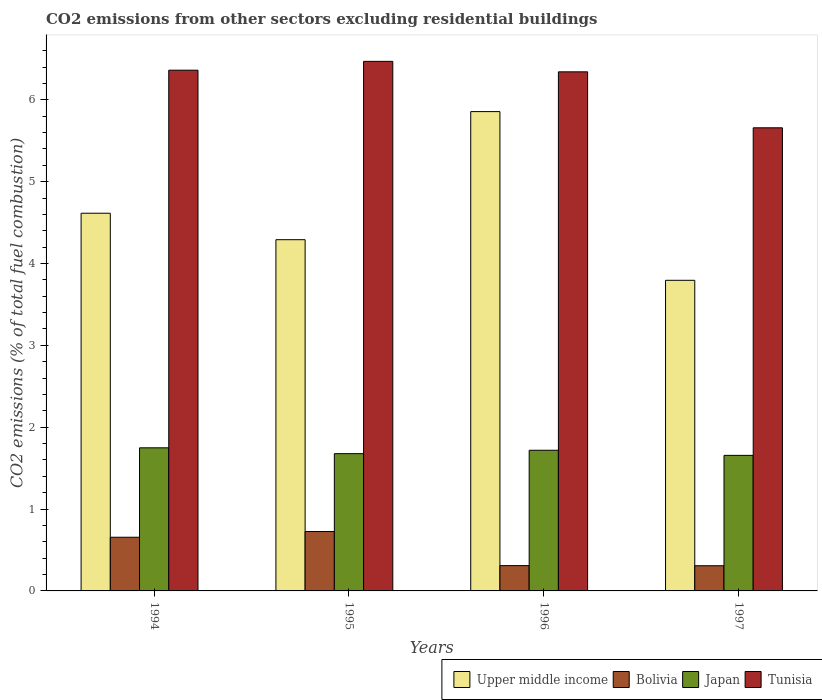How many different coloured bars are there?
Give a very brief answer. 4. How many groups of bars are there?
Offer a terse response. 4. Are the number of bars per tick equal to the number of legend labels?
Your answer should be very brief. Yes. How many bars are there on the 4th tick from the left?
Your answer should be very brief. 4. What is the label of the 1st group of bars from the left?
Keep it short and to the point. 1994. In how many cases, is the number of bars for a given year not equal to the number of legend labels?
Offer a very short reply. 0. What is the total CO2 emitted in Bolivia in 1997?
Provide a short and direct response. 0.31. Across all years, what is the maximum total CO2 emitted in Bolivia?
Offer a very short reply. 0.73. Across all years, what is the minimum total CO2 emitted in Japan?
Your response must be concise. 1.66. In which year was the total CO2 emitted in Bolivia minimum?
Offer a very short reply. 1997. What is the total total CO2 emitted in Japan in the graph?
Provide a short and direct response. 6.8. What is the difference between the total CO2 emitted in Bolivia in 1996 and that in 1997?
Give a very brief answer. 0. What is the difference between the total CO2 emitted in Tunisia in 1997 and the total CO2 emitted in Upper middle income in 1995?
Keep it short and to the point. 1.37. What is the average total CO2 emitted in Bolivia per year?
Your answer should be compact. 0.5. In the year 1995, what is the difference between the total CO2 emitted in Upper middle income and total CO2 emitted in Bolivia?
Provide a short and direct response. 3.57. What is the ratio of the total CO2 emitted in Bolivia in 1995 to that in 1997?
Provide a short and direct response. 2.36. What is the difference between the highest and the second highest total CO2 emitted in Tunisia?
Provide a short and direct response. 0.11. What is the difference between the highest and the lowest total CO2 emitted in Japan?
Offer a terse response. 0.09. Is the sum of the total CO2 emitted in Bolivia in 1994 and 1995 greater than the maximum total CO2 emitted in Japan across all years?
Your response must be concise. No. What does the 4th bar from the left in 1996 represents?
Offer a terse response. Tunisia. What does the 4th bar from the right in 1994 represents?
Give a very brief answer. Upper middle income. Is it the case that in every year, the sum of the total CO2 emitted in Japan and total CO2 emitted in Bolivia is greater than the total CO2 emitted in Upper middle income?
Give a very brief answer. No. Are all the bars in the graph horizontal?
Ensure brevity in your answer.  No. How many years are there in the graph?
Give a very brief answer. 4. Does the graph contain any zero values?
Make the answer very short. No. What is the title of the graph?
Ensure brevity in your answer.  CO2 emissions from other sectors excluding residential buildings. Does "Israel" appear as one of the legend labels in the graph?
Make the answer very short. No. What is the label or title of the Y-axis?
Provide a succinct answer. CO2 emissions (% of total fuel combustion). What is the CO2 emissions (% of total fuel combustion) of Upper middle income in 1994?
Make the answer very short. 4.61. What is the CO2 emissions (% of total fuel combustion) in Bolivia in 1994?
Offer a terse response. 0.66. What is the CO2 emissions (% of total fuel combustion) of Japan in 1994?
Keep it short and to the point. 1.75. What is the CO2 emissions (% of total fuel combustion) in Tunisia in 1994?
Make the answer very short. 6.36. What is the CO2 emissions (% of total fuel combustion) in Upper middle income in 1995?
Offer a very short reply. 4.29. What is the CO2 emissions (% of total fuel combustion) of Bolivia in 1995?
Ensure brevity in your answer.  0.73. What is the CO2 emissions (% of total fuel combustion) in Japan in 1995?
Your response must be concise. 1.68. What is the CO2 emissions (% of total fuel combustion) in Tunisia in 1995?
Provide a short and direct response. 6.47. What is the CO2 emissions (% of total fuel combustion) in Upper middle income in 1996?
Your answer should be compact. 5.86. What is the CO2 emissions (% of total fuel combustion) of Bolivia in 1996?
Offer a terse response. 0.31. What is the CO2 emissions (% of total fuel combustion) in Japan in 1996?
Your answer should be compact. 1.72. What is the CO2 emissions (% of total fuel combustion) of Tunisia in 1996?
Ensure brevity in your answer.  6.34. What is the CO2 emissions (% of total fuel combustion) of Upper middle income in 1997?
Offer a terse response. 3.79. What is the CO2 emissions (% of total fuel combustion) of Bolivia in 1997?
Ensure brevity in your answer.  0.31. What is the CO2 emissions (% of total fuel combustion) in Japan in 1997?
Offer a very short reply. 1.66. What is the CO2 emissions (% of total fuel combustion) of Tunisia in 1997?
Offer a very short reply. 5.66. Across all years, what is the maximum CO2 emissions (% of total fuel combustion) in Upper middle income?
Provide a succinct answer. 5.86. Across all years, what is the maximum CO2 emissions (% of total fuel combustion) in Bolivia?
Ensure brevity in your answer.  0.73. Across all years, what is the maximum CO2 emissions (% of total fuel combustion) in Japan?
Give a very brief answer. 1.75. Across all years, what is the maximum CO2 emissions (% of total fuel combustion) in Tunisia?
Keep it short and to the point. 6.47. Across all years, what is the minimum CO2 emissions (% of total fuel combustion) in Upper middle income?
Provide a short and direct response. 3.79. Across all years, what is the minimum CO2 emissions (% of total fuel combustion) in Bolivia?
Provide a succinct answer. 0.31. Across all years, what is the minimum CO2 emissions (% of total fuel combustion) in Japan?
Keep it short and to the point. 1.66. Across all years, what is the minimum CO2 emissions (% of total fuel combustion) of Tunisia?
Ensure brevity in your answer.  5.66. What is the total CO2 emissions (% of total fuel combustion) in Upper middle income in the graph?
Keep it short and to the point. 18.56. What is the total CO2 emissions (% of total fuel combustion) of Bolivia in the graph?
Ensure brevity in your answer.  2. What is the total CO2 emissions (% of total fuel combustion) of Japan in the graph?
Your answer should be compact. 6.8. What is the total CO2 emissions (% of total fuel combustion) of Tunisia in the graph?
Provide a succinct answer. 24.83. What is the difference between the CO2 emissions (% of total fuel combustion) of Upper middle income in 1994 and that in 1995?
Keep it short and to the point. 0.32. What is the difference between the CO2 emissions (% of total fuel combustion) in Bolivia in 1994 and that in 1995?
Offer a very short reply. -0.07. What is the difference between the CO2 emissions (% of total fuel combustion) of Japan in 1994 and that in 1995?
Offer a very short reply. 0.07. What is the difference between the CO2 emissions (% of total fuel combustion) in Tunisia in 1994 and that in 1995?
Your response must be concise. -0.11. What is the difference between the CO2 emissions (% of total fuel combustion) of Upper middle income in 1994 and that in 1996?
Offer a terse response. -1.24. What is the difference between the CO2 emissions (% of total fuel combustion) of Bolivia in 1994 and that in 1996?
Give a very brief answer. 0.35. What is the difference between the CO2 emissions (% of total fuel combustion) of Japan in 1994 and that in 1996?
Your response must be concise. 0.03. What is the difference between the CO2 emissions (% of total fuel combustion) of Tunisia in 1994 and that in 1996?
Give a very brief answer. 0.02. What is the difference between the CO2 emissions (% of total fuel combustion) in Upper middle income in 1994 and that in 1997?
Provide a succinct answer. 0.82. What is the difference between the CO2 emissions (% of total fuel combustion) in Bolivia in 1994 and that in 1997?
Offer a terse response. 0.35. What is the difference between the CO2 emissions (% of total fuel combustion) in Japan in 1994 and that in 1997?
Your response must be concise. 0.09. What is the difference between the CO2 emissions (% of total fuel combustion) in Tunisia in 1994 and that in 1997?
Your answer should be compact. 0.7. What is the difference between the CO2 emissions (% of total fuel combustion) of Upper middle income in 1995 and that in 1996?
Provide a short and direct response. -1.56. What is the difference between the CO2 emissions (% of total fuel combustion) of Bolivia in 1995 and that in 1996?
Offer a very short reply. 0.42. What is the difference between the CO2 emissions (% of total fuel combustion) in Japan in 1995 and that in 1996?
Make the answer very short. -0.04. What is the difference between the CO2 emissions (% of total fuel combustion) of Tunisia in 1995 and that in 1996?
Offer a terse response. 0.13. What is the difference between the CO2 emissions (% of total fuel combustion) in Upper middle income in 1995 and that in 1997?
Your response must be concise. 0.5. What is the difference between the CO2 emissions (% of total fuel combustion) of Bolivia in 1995 and that in 1997?
Ensure brevity in your answer.  0.42. What is the difference between the CO2 emissions (% of total fuel combustion) in Japan in 1995 and that in 1997?
Make the answer very short. 0.02. What is the difference between the CO2 emissions (% of total fuel combustion) in Tunisia in 1995 and that in 1997?
Your answer should be compact. 0.81. What is the difference between the CO2 emissions (% of total fuel combustion) of Upper middle income in 1996 and that in 1997?
Give a very brief answer. 2.06. What is the difference between the CO2 emissions (% of total fuel combustion) in Bolivia in 1996 and that in 1997?
Make the answer very short. 0. What is the difference between the CO2 emissions (% of total fuel combustion) of Japan in 1996 and that in 1997?
Ensure brevity in your answer.  0.06. What is the difference between the CO2 emissions (% of total fuel combustion) of Tunisia in 1996 and that in 1997?
Keep it short and to the point. 0.68. What is the difference between the CO2 emissions (% of total fuel combustion) in Upper middle income in 1994 and the CO2 emissions (% of total fuel combustion) in Bolivia in 1995?
Ensure brevity in your answer.  3.89. What is the difference between the CO2 emissions (% of total fuel combustion) in Upper middle income in 1994 and the CO2 emissions (% of total fuel combustion) in Japan in 1995?
Make the answer very short. 2.94. What is the difference between the CO2 emissions (% of total fuel combustion) in Upper middle income in 1994 and the CO2 emissions (% of total fuel combustion) in Tunisia in 1995?
Provide a short and direct response. -1.86. What is the difference between the CO2 emissions (% of total fuel combustion) in Bolivia in 1994 and the CO2 emissions (% of total fuel combustion) in Japan in 1995?
Offer a very short reply. -1.02. What is the difference between the CO2 emissions (% of total fuel combustion) of Bolivia in 1994 and the CO2 emissions (% of total fuel combustion) of Tunisia in 1995?
Your answer should be very brief. -5.81. What is the difference between the CO2 emissions (% of total fuel combustion) of Japan in 1994 and the CO2 emissions (% of total fuel combustion) of Tunisia in 1995?
Provide a short and direct response. -4.72. What is the difference between the CO2 emissions (% of total fuel combustion) in Upper middle income in 1994 and the CO2 emissions (% of total fuel combustion) in Bolivia in 1996?
Your answer should be compact. 4.31. What is the difference between the CO2 emissions (% of total fuel combustion) of Upper middle income in 1994 and the CO2 emissions (% of total fuel combustion) of Japan in 1996?
Your answer should be compact. 2.9. What is the difference between the CO2 emissions (% of total fuel combustion) in Upper middle income in 1994 and the CO2 emissions (% of total fuel combustion) in Tunisia in 1996?
Give a very brief answer. -1.73. What is the difference between the CO2 emissions (% of total fuel combustion) of Bolivia in 1994 and the CO2 emissions (% of total fuel combustion) of Japan in 1996?
Your answer should be very brief. -1.06. What is the difference between the CO2 emissions (% of total fuel combustion) of Bolivia in 1994 and the CO2 emissions (% of total fuel combustion) of Tunisia in 1996?
Your answer should be very brief. -5.69. What is the difference between the CO2 emissions (% of total fuel combustion) in Japan in 1994 and the CO2 emissions (% of total fuel combustion) in Tunisia in 1996?
Your answer should be compact. -4.59. What is the difference between the CO2 emissions (% of total fuel combustion) of Upper middle income in 1994 and the CO2 emissions (% of total fuel combustion) of Bolivia in 1997?
Give a very brief answer. 4.31. What is the difference between the CO2 emissions (% of total fuel combustion) of Upper middle income in 1994 and the CO2 emissions (% of total fuel combustion) of Japan in 1997?
Ensure brevity in your answer.  2.96. What is the difference between the CO2 emissions (% of total fuel combustion) in Upper middle income in 1994 and the CO2 emissions (% of total fuel combustion) in Tunisia in 1997?
Ensure brevity in your answer.  -1.04. What is the difference between the CO2 emissions (% of total fuel combustion) in Bolivia in 1994 and the CO2 emissions (% of total fuel combustion) in Japan in 1997?
Your answer should be compact. -1. What is the difference between the CO2 emissions (% of total fuel combustion) in Bolivia in 1994 and the CO2 emissions (% of total fuel combustion) in Tunisia in 1997?
Offer a terse response. -5. What is the difference between the CO2 emissions (% of total fuel combustion) in Japan in 1994 and the CO2 emissions (% of total fuel combustion) in Tunisia in 1997?
Your answer should be very brief. -3.91. What is the difference between the CO2 emissions (% of total fuel combustion) of Upper middle income in 1995 and the CO2 emissions (% of total fuel combustion) of Bolivia in 1996?
Give a very brief answer. 3.98. What is the difference between the CO2 emissions (% of total fuel combustion) of Upper middle income in 1995 and the CO2 emissions (% of total fuel combustion) of Japan in 1996?
Keep it short and to the point. 2.57. What is the difference between the CO2 emissions (% of total fuel combustion) in Upper middle income in 1995 and the CO2 emissions (% of total fuel combustion) in Tunisia in 1996?
Your answer should be compact. -2.05. What is the difference between the CO2 emissions (% of total fuel combustion) in Bolivia in 1995 and the CO2 emissions (% of total fuel combustion) in Japan in 1996?
Make the answer very short. -0.99. What is the difference between the CO2 emissions (% of total fuel combustion) in Bolivia in 1995 and the CO2 emissions (% of total fuel combustion) in Tunisia in 1996?
Offer a very short reply. -5.62. What is the difference between the CO2 emissions (% of total fuel combustion) of Japan in 1995 and the CO2 emissions (% of total fuel combustion) of Tunisia in 1996?
Ensure brevity in your answer.  -4.67. What is the difference between the CO2 emissions (% of total fuel combustion) in Upper middle income in 1995 and the CO2 emissions (% of total fuel combustion) in Bolivia in 1997?
Keep it short and to the point. 3.98. What is the difference between the CO2 emissions (% of total fuel combustion) in Upper middle income in 1995 and the CO2 emissions (% of total fuel combustion) in Japan in 1997?
Offer a terse response. 2.63. What is the difference between the CO2 emissions (% of total fuel combustion) in Upper middle income in 1995 and the CO2 emissions (% of total fuel combustion) in Tunisia in 1997?
Your answer should be very brief. -1.37. What is the difference between the CO2 emissions (% of total fuel combustion) in Bolivia in 1995 and the CO2 emissions (% of total fuel combustion) in Japan in 1997?
Offer a very short reply. -0.93. What is the difference between the CO2 emissions (% of total fuel combustion) in Bolivia in 1995 and the CO2 emissions (% of total fuel combustion) in Tunisia in 1997?
Make the answer very short. -4.93. What is the difference between the CO2 emissions (% of total fuel combustion) in Japan in 1995 and the CO2 emissions (% of total fuel combustion) in Tunisia in 1997?
Provide a short and direct response. -3.98. What is the difference between the CO2 emissions (% of total fuel combustion) of Upper middle income in 1996 and the CO2 emissions (% of total fuel combustion) of Bolivia in 1997?
Offer a very short reply. 5.55. What is the difference between the CO2 emissions (% of total fuel combustion) in Upper middle income in 1996 and the CO2 emissions (% of total fuel combustion) in Japan in 1997?
Your response must be concise. 4.2. What is the difference between the CO2 emissions (% of total fuel combustion) in Upper middle income in 1996 and the CO2 emissions (% of total fuel combustion) in Tunisia in 1997?
Your response must be concise. 0.2. What is the difference between the CO2 emissions (% of total fuel combustion) of Bolivia in 1996 and the CO2 emissions (% of total fuel combustion) of Japan in 1997?
Provide a short and direct response. -1.35. What is the difference between the CO2 emissions (% of total fuel combustion) in Bolivia in 1996 and the CO2 emissions (% of total fuel combustion) in Tunisia in 1997?
Provide a succinct answer. -5.35. What is the difference between the CO2 emissions (% of total fuel combustion) in Japan in 1996 and the CO2 emissions (% of total fuel combustion) in Tunisia in 1997?
Offer a very short reply. -3.94. What is the average CO2 emissions (% of total fuel combustion) of Upper middle income per year?
Provide a short and direct response. 4.64. What is the average CO2 emissions (% of total fuel combustion) in Bolivia per year?
Ensure brevity in your answer.  0.5. What is the average CO2 emissions (% of total fuel combustion) in Japan per year?
Keep it short and to the point. 1.7. What is the average CO2 emissions (% of total fuel combustion) in Tunisia per year?
Make the answer very short. 6.21. In the year 1994, what is the difference between the CO2 emissions (% of total fuel combustion) of Upper middle income and CO2 emissions (% of total fuel combustion) of Bolivia?
Your answer should be compact. 3.96. In the year 1994, what is the difference between the CO2 emissions (% of total fuel combustion) in Upper middle income and CO2 emissions (% of total fuel combustion) in Japan?
Give a very brief answer. 2.87. In the year 1994, what is the difference between the CO2 emissions (% of total fuel combustion) in Upper middle income and CO2 emissions (% of total fuel combustion) in Tunisia?
Give a very brief answer. -1.75. In the year 1994, what is the difference between the CO2 emissions (% of total fuel combustion) of Bolivia and CO2 emissions (% of total fuel combustion) of Japan?
Make the answer very short. -1.09. In the year 1994, what is the difference between the CO2 emissions (% of total fuel combustion) in Bolivia and CO2 emissions (% of total fuel combustion) in Tunisia?
Provide a succinct answer. -5.71. In the year 1994, what is the difference between the CO2 emissions (% of total fuel combustion) of Japan and CO2 emissions (% of total fuel combustion) of Tunisia?
Your answer should be compact. -4.61. In the year 1995, what is the difference between the CO2 emissions (% of total fuel combustion) of Upper middle income and CO2 emissions (% of total fuel combustion) of Bolivia?
Offer a very short reply. 3.57. In the year 1995, what is the difference between the CO2 emissions (% of total fuel combustion) of Upper middle income and CO2 emissions (% of total fuel combustion) of Japan?
Your answer should be compact. 2.61. In the year 1995, what is the difference between the CO2 emissions (% of total fuel combustion) in Upper middle income and CO2 emissions (% of total fuel combustion) in Tunisia?
Offer a terse response. -2.18. In the year 1995, what is the difference between the CO2 emissions (% of total fuel combustion) of Bolivia and CO2 emissions (% of total fuel combustion) of Japan?
Your response must be concise. -0.95. In the year 1995, what is the difference between the CO2 emissions (% of total fuel combustion) in Bolivia and CO2 emissions (% of total fuel combustion) in Tunisia?
Provide a succinct answer. -5.74. In the year 1995, what is the difference between the CO2 emissions (% of total fuel combustion) in Japan and CO2 emissions (% of total fuel combustion) in Tunisia?
Your response must be concise. -4.79. In the year 1996, what is the difference between the CO2 emissions (% of total fuel combustion) of Upper middle income and CO2 emissions (% of total fuel combustion) of Bolivia?
Your answer should be very brief. 5.55. In the year 1996, what is the difference between the CO2 emissions (% of total fuel combustion) of Upper middle income and CO2 emissions (% of total fuel combustion) of Japan?
Your response must be concise. 4.14. In the year 1996, what is the difference between the CO2 emissions (% of total fuel combustion) in Upper middle income and CO2 emissions (% of total fuel combustion) in Tunisia?
Your response must be concise. -0.49. In the year 1996, what is the difference between the CO2 emissions (% of total fuel combustion) in Bolivia and CO2 emissions (% of total fuel combustion) in Japan?
Ensure brevity in your answer.  -1.41. In the year 1996, what is the difference between the CO2 emissions (% of total fuel combustion) of Bolivia and CO2 emissions (% of total fuel combustion) of Tunisia?
Offer a terse response. -6.03. In the year 1996, what is the difference between the CO2 emissions (% of total fuel combustion) of Japan and CO2 emissions (% of total fuel combustion) of Tunisia?
Your answer should be very brief. -4.62. In the year 1997, what is the difference between the CO2 emissions (% of total fuel combustion) in Upper middle income and CO2 emissions (% of total fuel combustion) in Bolivia?
Keep it short and to the point. 3.49. In the year 1997, what is the difference between the CO2 emissions (% of total fuel combustion) of Upper middle income and CO2 emissions (% of total fuel combustion) of Japan?
Provide a succinct answer. 2.14. In the year 1997, what is the difference between the CO2 emissions (% of total fuel combustion) of Upper middle income and CO2 emissions (% of total fuel combustion) of Tunisia?
Provide a succinct answer. -1.86. In the year 1997, what is the difference between the CO2 emissions (% of total fuel combustion) in Bolivia and CO2 emissions (% of total fuel combustion) in Japan?
Provide a short and direct response. -1.35. In the year 1997, what is the difference between the CO2 emissions (% of total fuel combustion) of Bolivia and CO2 emissions (% of total fuel combustion) of Tunisia?
Ensure brevity in your answer.  -5.35. In the year 1997, what is the difference between the CO2 emissions (% of total fuel combustion) in Japan and CO2 emissions (% of total fuel combustion) in Tunisia?
Offer a terse response. -4. What is the ratio of the CO2 emissions (% of total fuel combustion) in Upper middle income in 1994 to that in 1995?
Offer a terse response. 1.08. What is the ratio of the CO2 emissions (% of total fuel combustion) in Bolivia in 1994 to that in 1995?
Offer a terse response. 0.9. What is the ratio of the CO2 emissions (% of total fuel combustion) in Japan in 1994 to that in 1995?
Keep it short and to the point. 1.04. What is the ratio of the CO2 emissions (% of total fuel combustion) in Tunisia in 1994 to that in 1995?
Your answer should be very brief. 0.98. What is the ratio of the CO2 emissions (% of total fuel combustion) of Upper middle income in 1994 to that in 1996?
Offer a very short reply. 0.79. What is the ratio of the CO2 emissions (% of total fuel combustion) of Bolivia in 1994 to that in 1996?
Give a very brief answer. 2.12. What is the ratio of the CO2 emissions (% of total fuel combustion) of Japan in 1994 to that in 1996?
Your response must be concise. 1.02. What is the ratio of the CO2 emissions (% of total fuel combustion) of Upper middle income in 1994 to that in 1997?
Ensure brevity in your answer.  1.22. What is the ratio of the CO2 emissions (% of total fuel combustion) of Bolivia in 1994 to that in 1997?
Make the answer very short. 2.13. What is the ratio of the CO2 emissions (% of total fuel combustion) in Japan in 1994 to that in 1997?
Make the answer very short. 1.06. What is the ratio of the CO2 emissions (% of total fuel combustion) of Tunisia in 1994 to that in 1997?
Your answer should be compact. 1.12. What is the ratio of the CO2 emissions (% of total fuel combustion) in Upper middle income in 1995 to that in 1996?
Offer a terse response. 0.73. What is the ratio of the CO2 emissions (% of total fuel combustion) in Bolivia in 1995 to that in 1996?
Provide a succinct answer. 2.35. What is the ratio of the CO2 emissions (% of total fuel combustion) in Japan in 1995 to that in 1996?
Your answer should be very brief. 0.98. What is the ratio of the CO2 emissions (% of total fuel combustion) of Tunisia in 1995 to that in 1996?
Offer a terse response. 1.02. What is the ratio of the CO2 emissions (% of total fuel combustion) of Upper middle income in 1995 to that in 1997?
Provide a short and direct response. 1.13. What is the ratio of the CO2 emissions (% of total fuel combustion) of Bolivia in 1995 to that in 1997?
Make the answer very short. 2.36. What is the ratio of the CO2 emissions (% of total fuel combustion) in Japan in 1995 to that in 1997?
Your answer should be very brief. 1.01. What is the ratio of the CO2 emissions (% of total fuel combustion) of Tunisia in 1995 to that in 1997?
Provide a succinct answer. 1.14. What is the ratio of the CO2 emissions (% of total fuel combustion) in Upper middle income in 1996 to that in 1997?
Provide a succinct answer. 1.54. What is the ratio of the CO2 emissions (% of total fuel combustion) of Japan in 1996 to that in 1997?
Give a very brief answer. 1.04. What is the ratio of the CO2 emissions (% of total fuel combustion) in Tunisia in 1996 to that in 1997?
Your answer should be compact. 1.12. What is the difference between the highest and the second highest CO2 emissions (% of total fuel combustion) of Upper middle income?
Ensure brevity in your answer.  1.24. What is the difference between the highest and the second highest CO2 emissions (% of total fuel combustion) in Bolivia?
Your answer should be compact. 0.07. What is the difference between the highest and the second highest CO2 emissions (% of total fuel combustion) of Japan?
Provide a short and direct response. 0.03. What is the difference between the highest and the second highest CO2 emissions (% of total fuel combustion) of Tunisia?
Offer a terse response. 0.11. What is the difference between the highest and the lowest CO2 emissions (% of total fuel combustion) of Upper middle income?
Provide a short and direct response. 2.06. What is the difference between the highest and the lowest CO2 emissions (% of total fuel combustion) in Bolivia?
Provide a short and direct response. 0.42. What is the difference between the highest and the lowest CO2 emissions (% of total fuel combustion) in Japan?
Your response must be concise. 0.09. What is the difference between the highest and the lowest CO2 emissions (% of total fuel combustion) of Tunisia?
Make the answer very short. 0.81. 